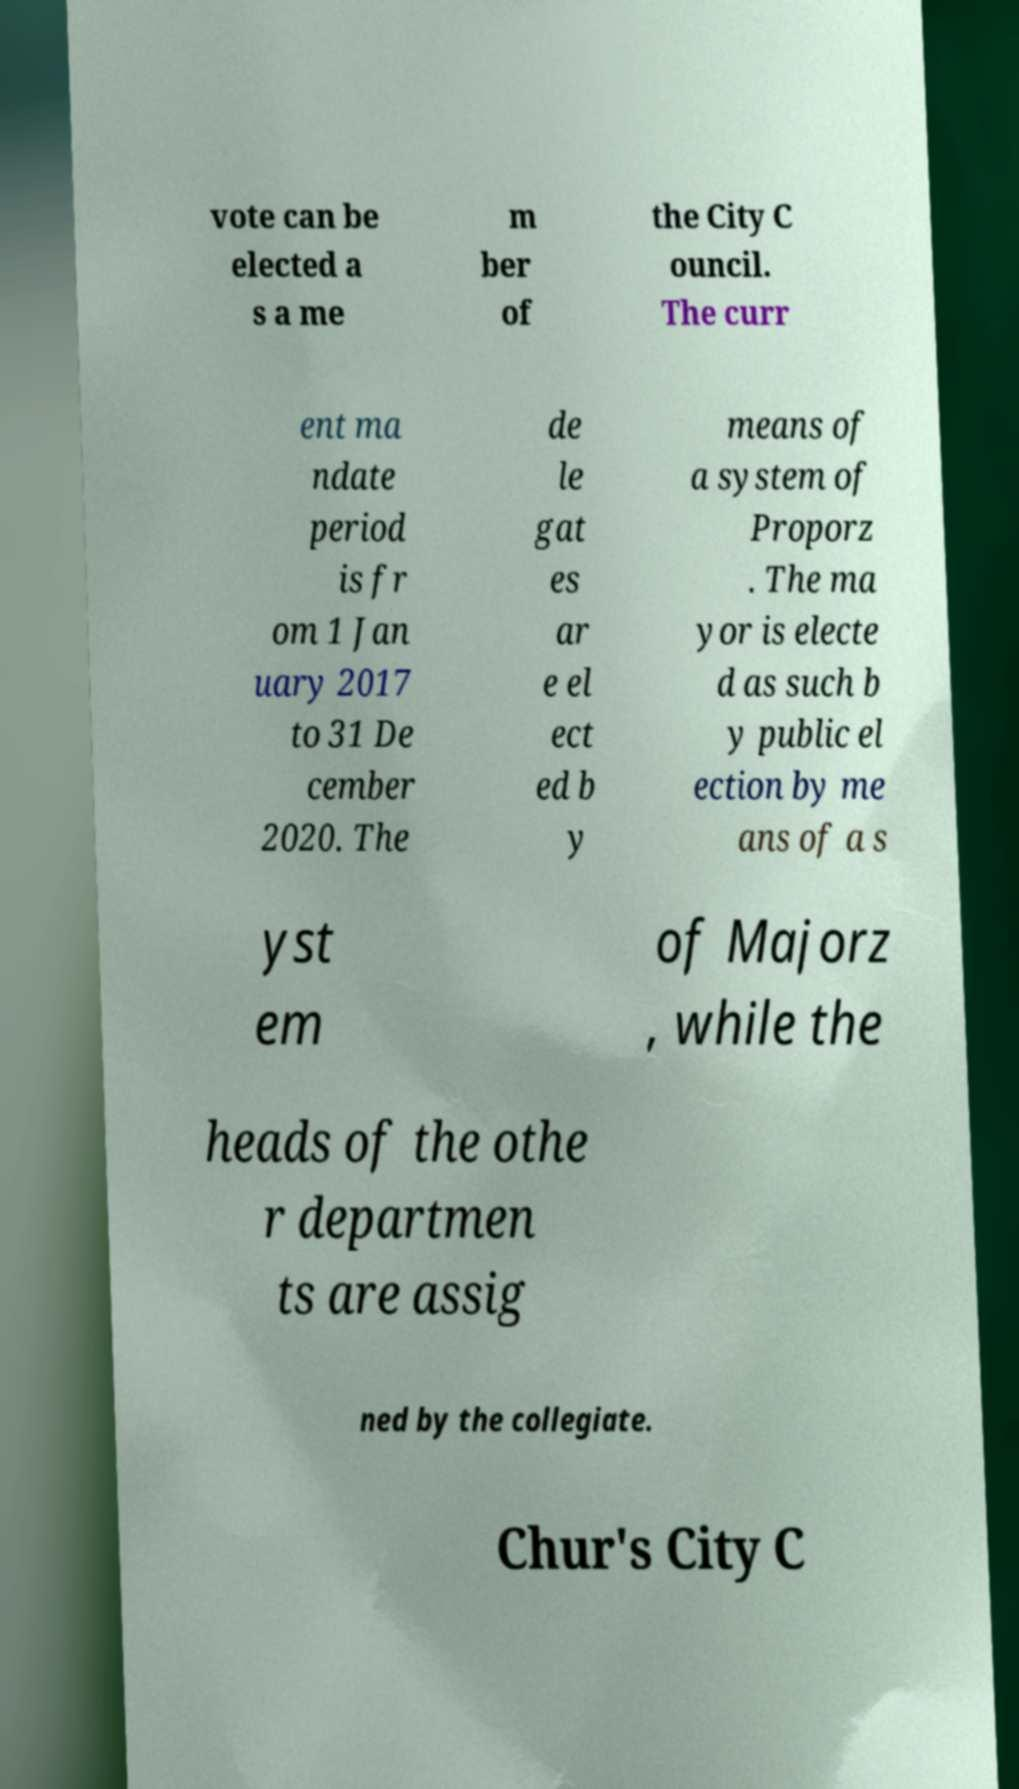Could you assist in decoding the text presented in this image and type it out clearly? vote can be elected a s a me m ber of the City C ouncil. The curr ent ma ndate period is fr om 1 Jan uary 2017 to 31 De cember 2020. The de le gat es ar e el ect ed b y means of a system of Proporz . The ma yor is electe d as such b y public el ection by me ans of a s yst em of Majorz , while the heads of the othe r departmen ts are assig ned by the collegiate. Chur's City C 